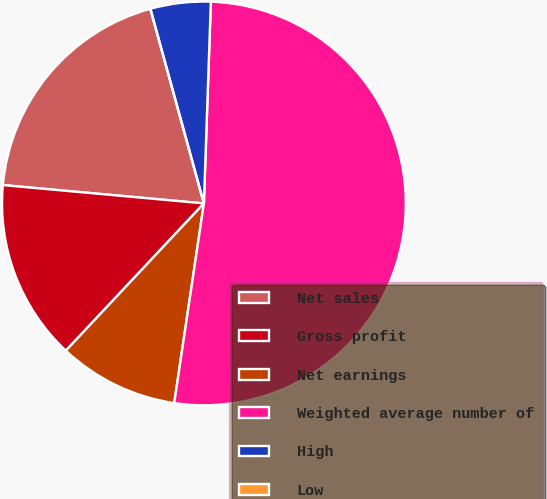Convert chart to OTSL. <chart><loc_0><loc_0><loc_500><loc_500><pie_chart><fcel>Net sales<fcel>Gross profit<fcel>Net earnings<fcel>Weighted average number of<fcel>High<fcel>Low<nl><fcel>19.28%<fcel>14.46%<fcel>9.64%<fcel>51.8%<fcel>4.82%<fcel>0.0%<nl></chart> 